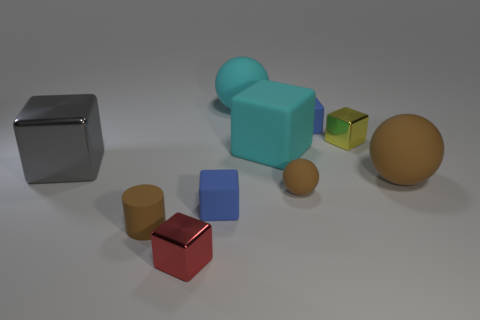Do the cylinder and the small ball have the same color?
Provide a short and direct response. Yes. Are there the same number of small red shiny objects that are to the right of the tiny yellow block and tiny red cubes that are behind the large shiny block?
Provide a short and direct response. Yes. What color is the small ball?
Provide a short and direct response. Brown. How many objects are either tiny brown rubber objects that are behind the brown matte cylinder or gray cylinders?
Your response must be concise. 1. There is a blue cube that is behind the yellow thing; is its size the same as the blue cube that is in front of the gray cube?
Make the answer very short. Yes. How many objects are either small brown things on the right side of the red cube or shiny objects in front of the tiny brown cylinder?
Give a very brief answer. 2. Is the material of the red block the same as the gray block in front of the large matte cube?
Ensure brevity in your answer.  Yes. The large rubber thing that is both to the left of the tiny sphere and in front of the big cyan ball has what shape?
Make the answer very short. Cube. How many other objects are the same color as the large metallic cube?
Give a very brief answer. 0. What is the shape of the small red object?
Ensure brevity in your answer.  Cube. 